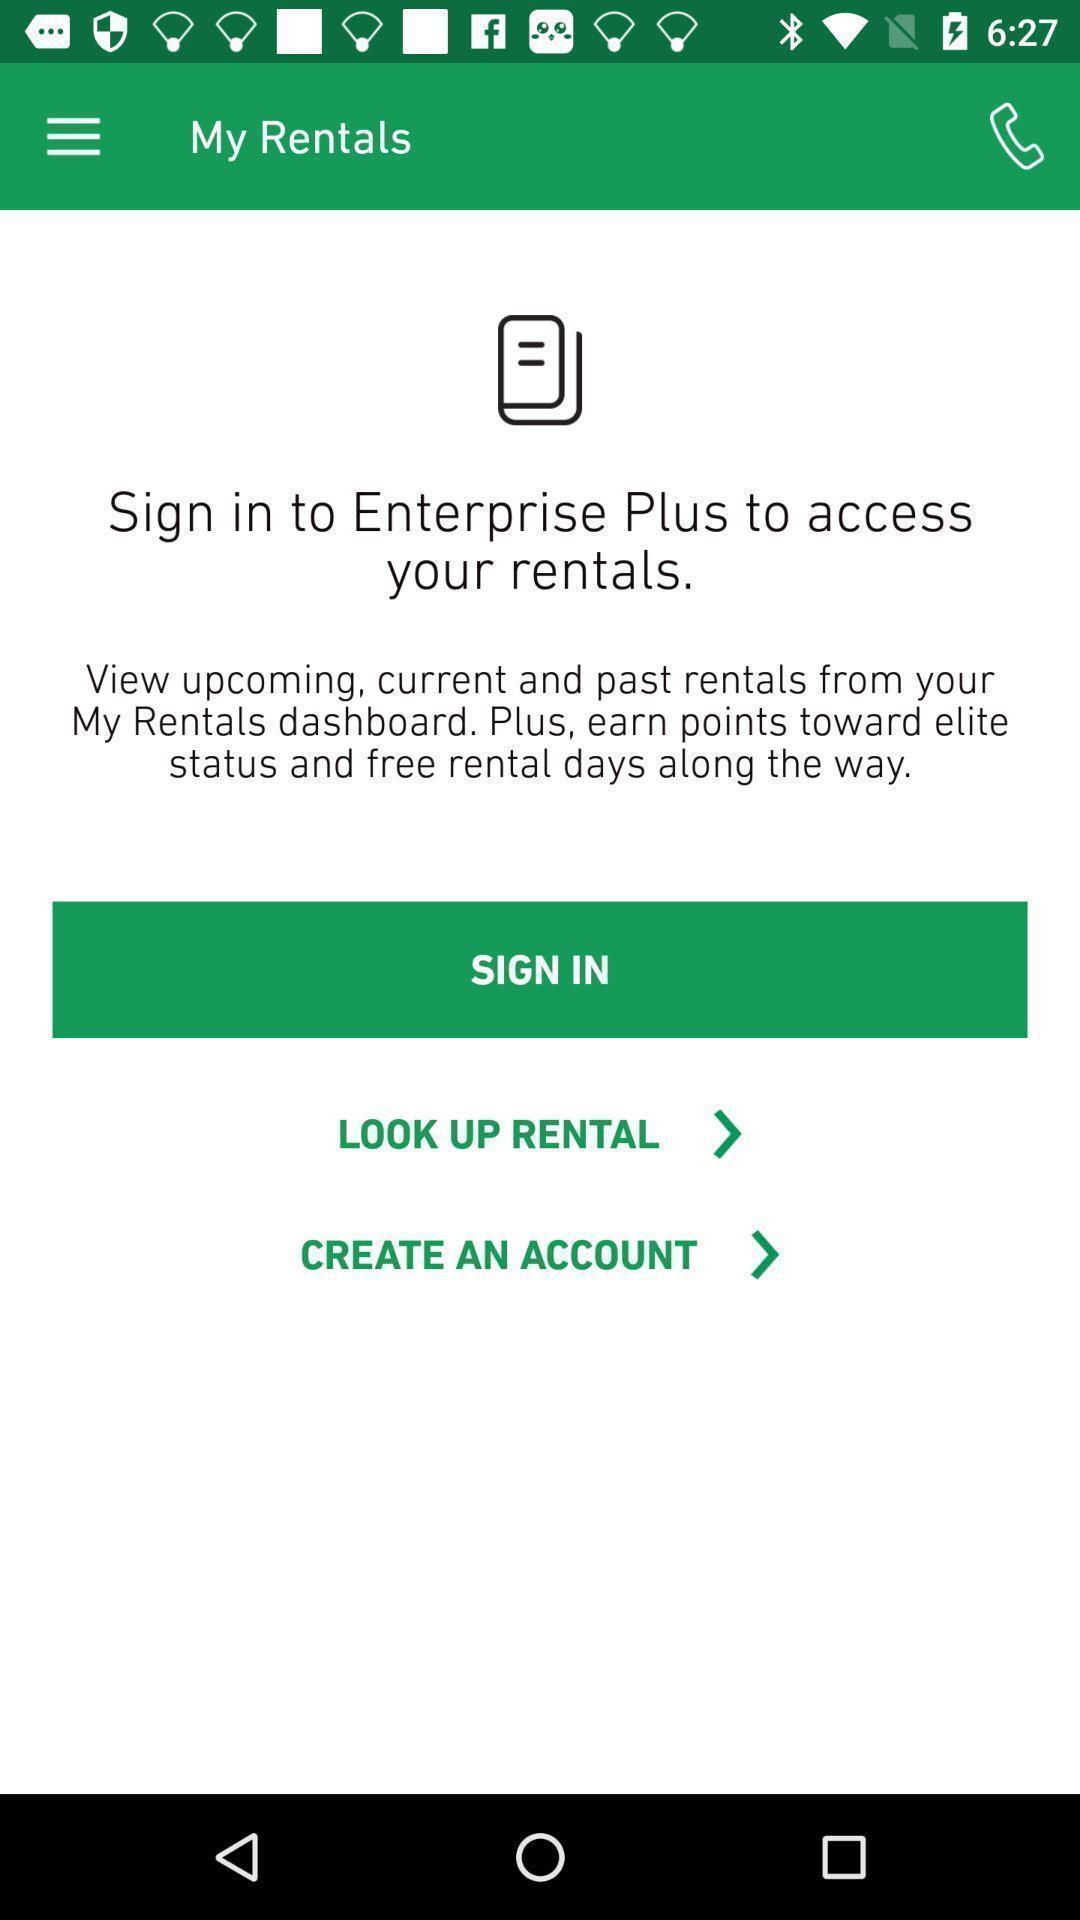What is the overall content of this screenshot? Welcome page for management app. 